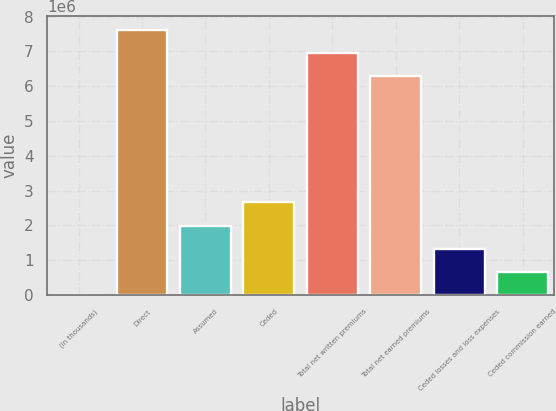<chart> <loc_0><loc_0><loc_500><loc_500><bar_chart><fcel>(In thousands)<fcel>Direct<fcel>Assumed<fcel>Ceded<fcel>Total net written premiums<fcel>Total net earned premiums<fcel>Ceded losses and loss expenses<fcel>Ceded commission earned<nl><fcel>2016<fcel>7.62246e+06<fcel>1.99569e+06<fcel>2.66025e+06<fcel>6.95791e+06<fcel>6.29335e+06<fcel>1.33113e+06<fcel>666574<nl></chart> 